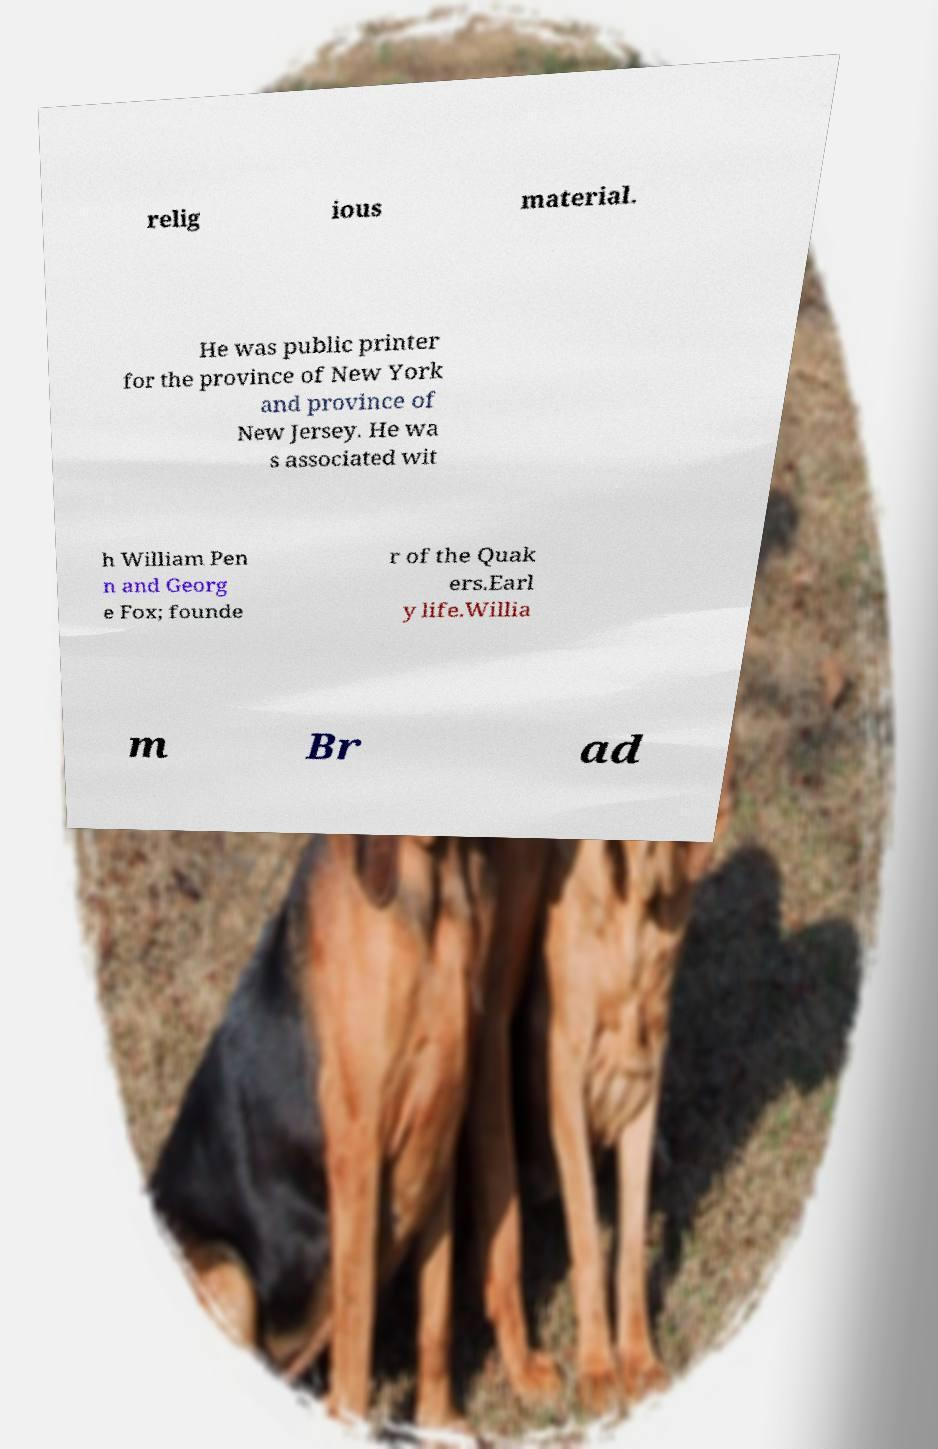Can you read and provide the text displayed in the image?This photo seems to have some interesting text. Can you extract and type it out for me? relig ious material. He was public printer for the province of New York and province of New Jersey. He wa s associated wit h William Pen n and Georg e Fox; founde r of the Quak ers.Earl y life.Willia m Br ad 